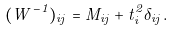Convert formula to latex. <formula><loc_0><loc_0><loc_500><loc_500>( W ^ { - 1 } ) _ { i j } = M _ { i j } + t _ { i } ^ { 2 } \delta _ { i j } .</formula> 